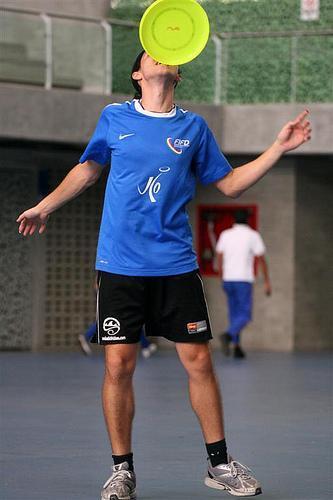How many frisbees are in the picture?
Give a very brief answer. 1. How many people are wearing black shorts?
Give a very brief answer. 1. 